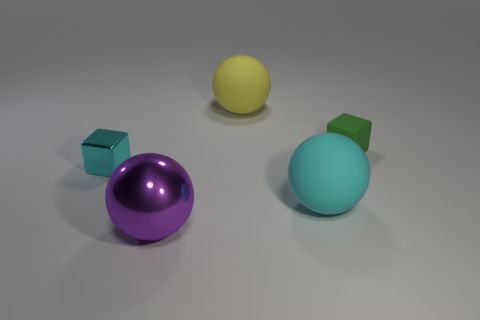Are there any shadows present, suggesting a light source? Yes, each object casts a shadow to its lower left side, suggesting that the light source is coming from the upper right of the scene. 